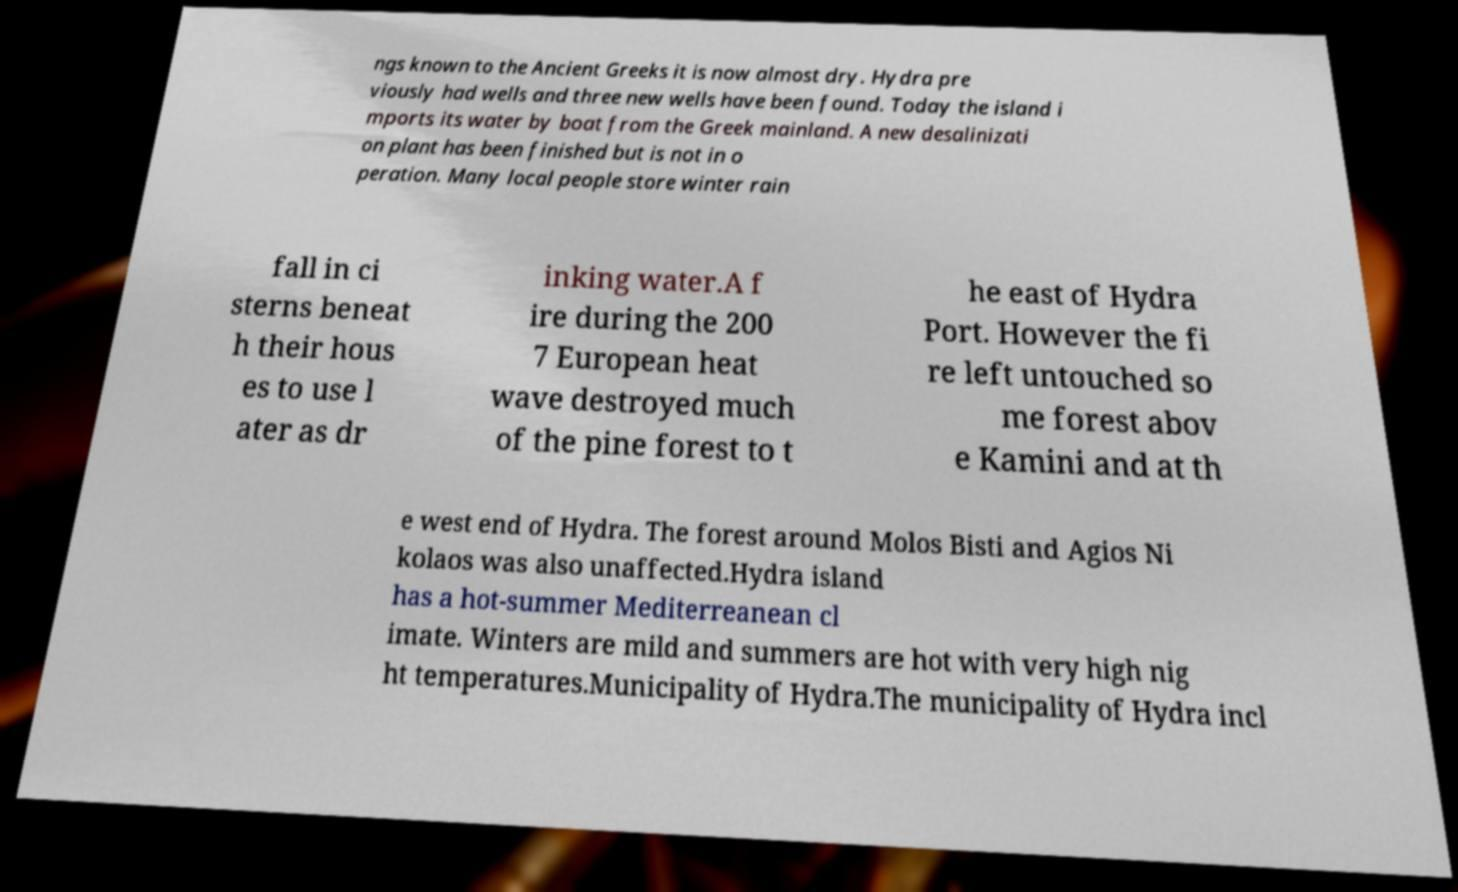Could you assist in decoding the text presented in this image and type it out clearly? ngs known to the Ancient Greeks it is now almost dry. Hydra pre viously had wells and three new wells have been found. Today the island i mports its water by boat from the Greek mainland. A new desalinizati on plant has been finished but is not in o peration. Many local people store winter rain fall in ci sterns beneat h their hous es to use l ater as dr inking water.A f ire during the 200 7 European heat wave destroyed much of the pine forest to t he east of Hydra Port. However the fi re left untouched so me forest abov e Kamini and at th e west end of Hydra. The forest around Molos Bisti and Agios Ni kolaos was also unaffected.Hydra island has a hot-summer Mediterreanean cl imate. Winters are mild and summers are hot with very high nig ht temperatures.Municipality of Hydra.The municipality of Hydra incl 